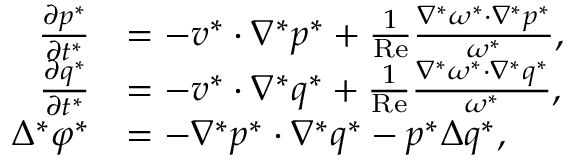Convert formula to latex. <formula><loc_0><loc_0><loc_500><loc_500>\begin{array} { r l } { \frac { \partial p ^ { * } } { \partial t ^ { * } } } & { = - v ^ { * } \cdot \nabla ^ { * } p ^ { * } + \frac { 1 } { R e } \frac { \nabla ^ { * } \omega ^ { * } \cdot \nabla ^ { * } p ^ { * } } { \omega ^ { * } } , } \\ { \frac { \partial q ^ { * } } { \partial t ^ { * } } } & { = - v ^ { * } \cdot \nabla ^ { * } q ^ { * } + \frac { 1 } { R e } \frac { \nabla ^ { * } \omega ^ { * } \cdot \nabla ^ { * } q ^ { * } } { \omega ^ { * } } , } \\ { \Delta ^ { * } \varphi ^ { * } } & { = - \nabla ^ { * } p ^ { * } \cdot \nabla ^ { * } q ^ { * } - p ^ { * } \Delta q ^ { * } , } \end{array}</formula> 